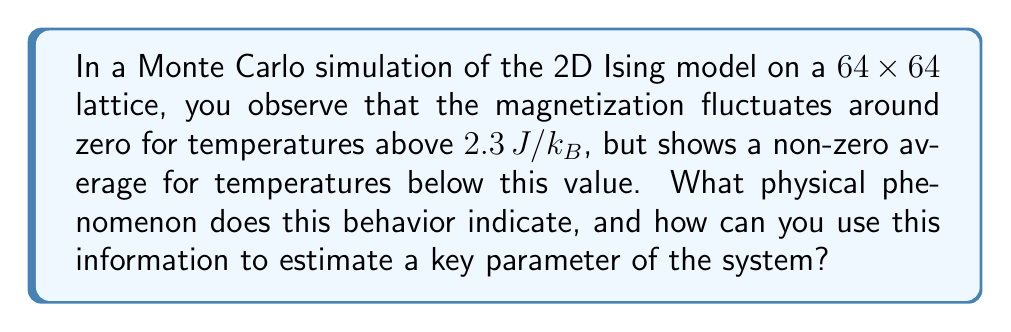Provide a solution to this math problem. To understand this problem, let's break it down step-by-step:

1) The Ising model is a simple model of ferromagnetism in statistical mechanics. In 2D, it exhibits a phase transition at a critical temperature $T_c$.

2) Monte Carlo simulations are computational methods used to study complex systems by random sampling. In this case, they're used to simulate the behavior of the Ising model at different temperatures.

3) Magnetization ($M$) is the order parameter for the Ising model. It's defined as:

   $$M = \frac{1}{N} \sum_{i=1}^N s_i$$

   where $N$ is the total number of spins and $s_i$ is the spin at site $i$.

4) The behavior described in the question is characteristic of a phase transition:
   - For $T > T_c$, $M$ fluctuates around zero (paramagnetic phase)
   - For $T < T_c$, $M$ has a non-zero average (ferromagnetic phase)

5) The temperature at which this change occurs (2.3 J/k_B in this case) is an estimate of the critical temperature $T_c$.

6) For the 2D Ising model, the exact solution for $T_c$ is known:

   $$T_c = \frac{2J}{k_B \ln(1+\sqrt{2})} \approx 2.269 J/k_B$$

7) The observed value (2.3 J/k_B) is very close to this exact value, demonstrating the power of Monte Carlo simulations in estimating critical parameters.

8) This phase transition is second-order, characterized by a continuous change in the order parameter ($M$) but a discontinuity in its derivatives.

In the context of software engineering, this problem illustrates how computational methods (like Monte Carlo simulations) can be used to study complex systems and estimate important parameters, much like how software testing and benchmarking are used to evaluate system performance and identify critical thresholds.
Answer: Phase transition at $T_c \approx 2.3 J/k_B$ 